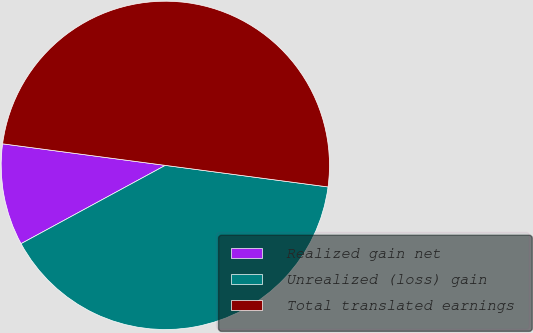Convert chart. <chart><loc_0><loc_0><loc_500><loc_500><pie_chart><fcel>Realized gain net<fcel>Unrealized (loss) gain<fcel>Total translated earnings<nl><fcel>10.01%<fcel>39.99%<fcel>50.0%<nl></chart> 